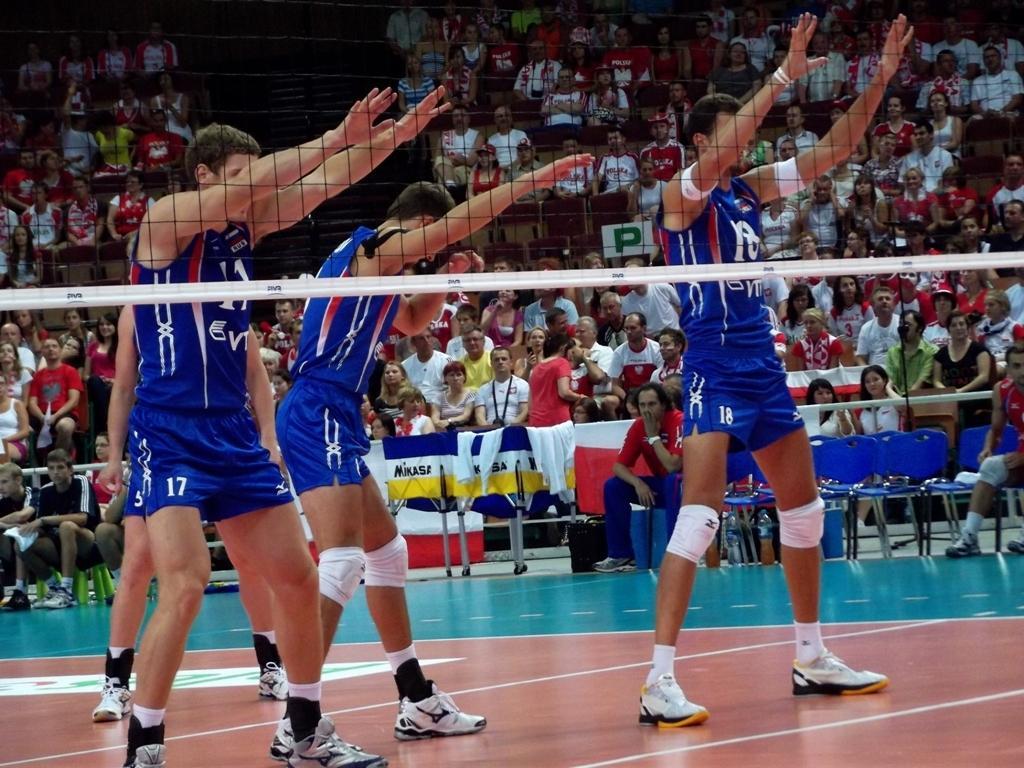How would you summarize this image in a sentence or two? In this image I can see there are four persons standing on the ground and they are wearing a blue color t-shirts and I can see the fence beside them and I can see chairs in the middle , on the chairs there are two persons sitting , at the top I can see crowd of people. 